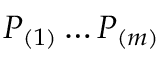<formula> <loc_0><loc_0><loc_500><loc_500>P _ { ( 1 ) } \dots P _ { ( m ) }</formula> 